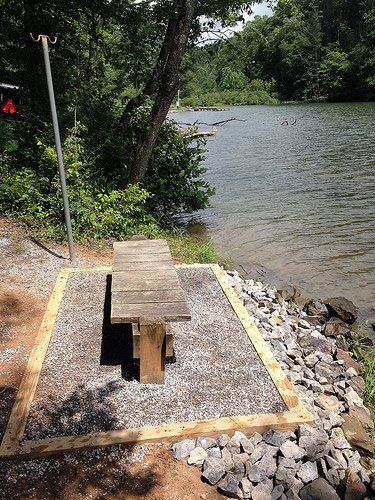<image>
Can you confirm if the tree is next to the water? Yes. The tree is positioned adjacent to the water, located nearby in the same general area. 